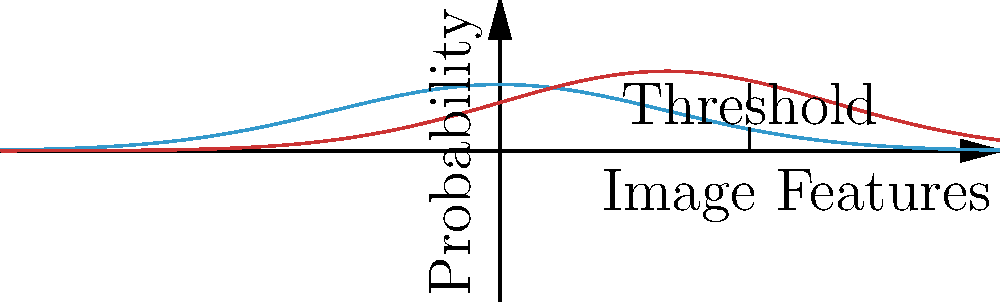As a fitness influencer promoting vaccination, you encounter an AI-based system for detecting fake vaccination certificates. The system uses a probabilistic approach based on image features. Given the probability distributions shown in the graph for real and fake certificates, at what threshold value would you set the system to minimize false positives (real certificates mistakenly classified as fake) while maintaining a reasonable detection rate for fake certificates? To answer this question, we need to analyze the graph and understand the trade-offs involved in setting the threshold:

1. The blue curve represents the probability distribution of features for real vaccination certificates, while the red curve represents fake certificates.

2. The x-axis represents image features, and the y-axis represents the probability density.

3. The goal is to minimize false positives (real certificates classified as fake) while maintaining a reasonable detection rate for fake certificates.

4. Observing the graph, we can see that the two distributions overlap, which means there's no perfect threshold that completely separates real and fake certificates.

5. The ideal threshold should be where the two curves intersect or slightly to the right of this point. This location balances the trade-off between false positives and false negatives.

6. The intersection point appears to be around x = 1.5 on the graph.

7. Setting the threshold at 1.5 would:
   a) Minimize false positives, as most of the area under the blue curve (real certificates) is to the left of this point.
   b) Maintain a reasonable detection rate for fake certificates, as a significant portion of the area under the red curve (fake certificates) is to the right of this point.

8. While a lower threshold might catch more fake certificates, it would also increase false positives, which could damage your credibility as a fitness influencer promoting vaccination.

9. A higher threshold would reduce false positives further but might miss too many fake certificates, compromising the system's effectiveness.

Therefore, based on the graph and the goals stated in the question, setting the threshold at approximately 1.5 would be the most appropriate choice.
Answer: 1.5 